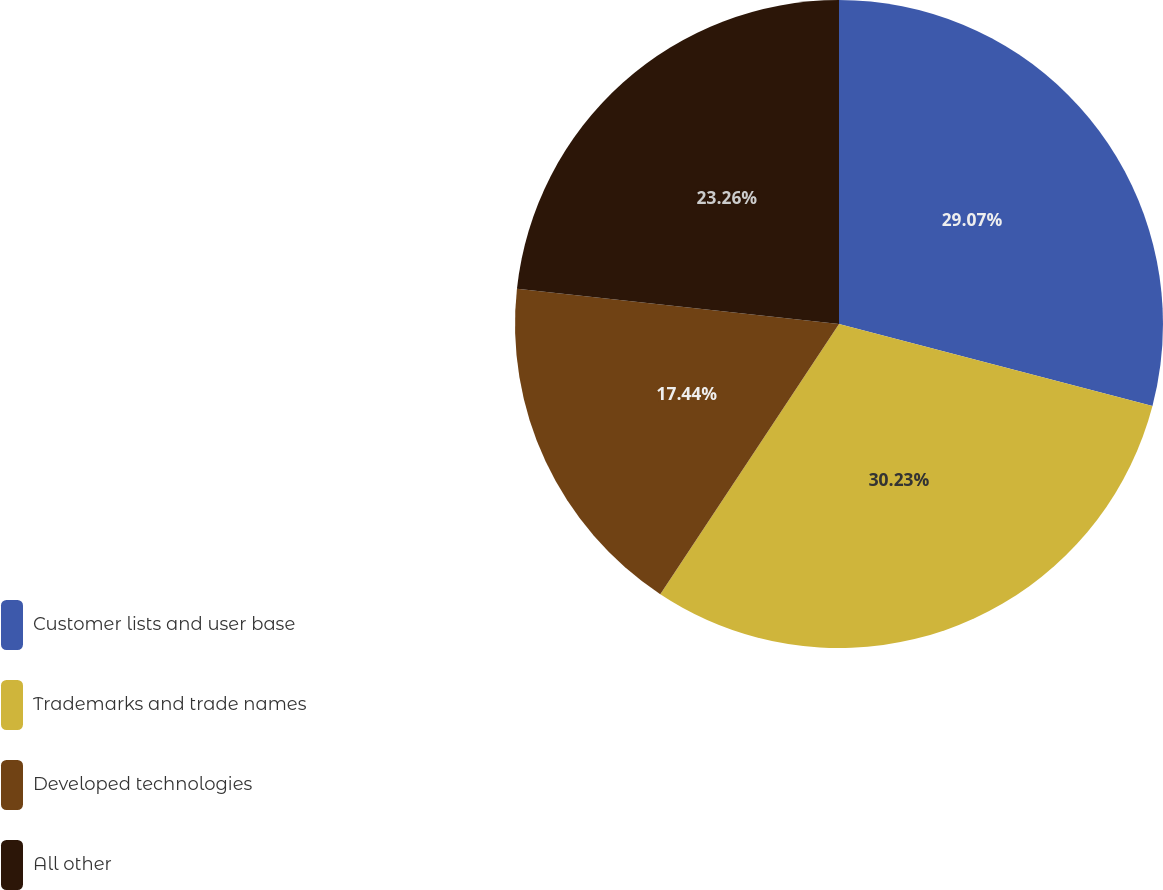<chart> <loc_0><loc_0><loc_500><loc_500><pie_chart><fcel>Customer lists and user base<fcel>Trademarks and trade names<fcel>Developed technologies<fcel>All other<nl><fcel>29.07%<fcel>30.23%<fcel>17.44%<fcel>23.26%<nl></chart> 